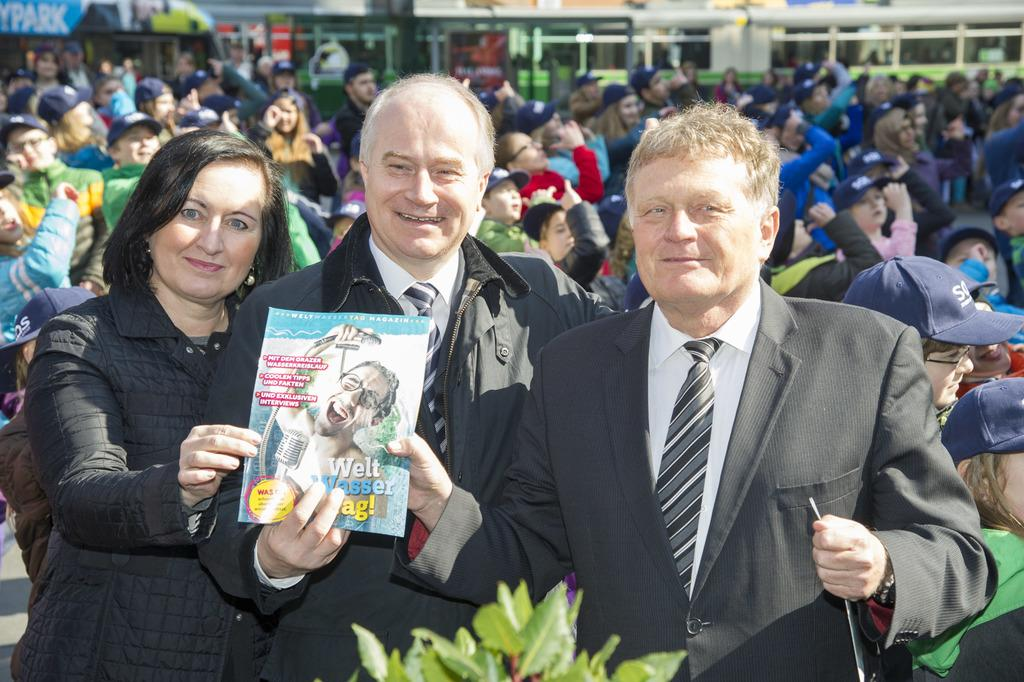How many people are in the image? There are three persons in the image. What are the three persons holding? The three persons are holding a book. Can you describe the background of the image? There is a group of people in the background of the image. What type of board can be seen in the image? There is no board present in the image. What kind of seed is being planted by the persons in the image? There is no seed or planting activity depicted in the image; the three persons are holding a book. 